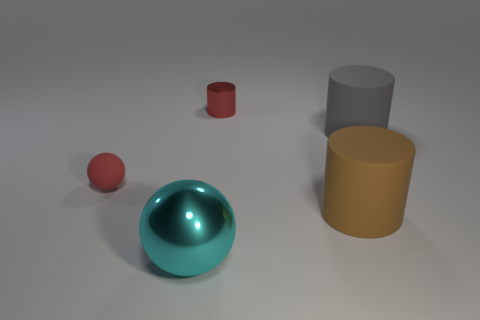Is there a green metallic cylinder of the same size as the brown cylinder?
Offer a terse response. No. Is the shape of the tiny thing to the right of the tiny sphere the same as  the brown thing?
Your answer should be very brief. Yes. What material is the tiny thing that is left of the small metal cylinder?
Offer a very short reply. Rubber. What is the shape of the thing left of the metal sphere to the left of the large brown matte thing?
Offer a terse response. Sphere. There is a brown thing; does it have the same shape as the thing that is in front of the brown thing?
Provide a short and direct response. No. How many tiny things are to the right of the shiny thing that is in front of the small red cylinder?
Make the answer very short. 1. There is a big gray object that is the same shape as the small red metal object; what is its material?
Offer a very short reply. Rubber. What number of yellow things are small rubber spheres or small shiny things?
Provide a short and direct response. 0. Is there any other thing of the same color as the small matte sphere?
Offer a very short reply. Yes. What color is the small object in front of the small thing that is right of the cyan object?
Keep it short and to the point. Red. 